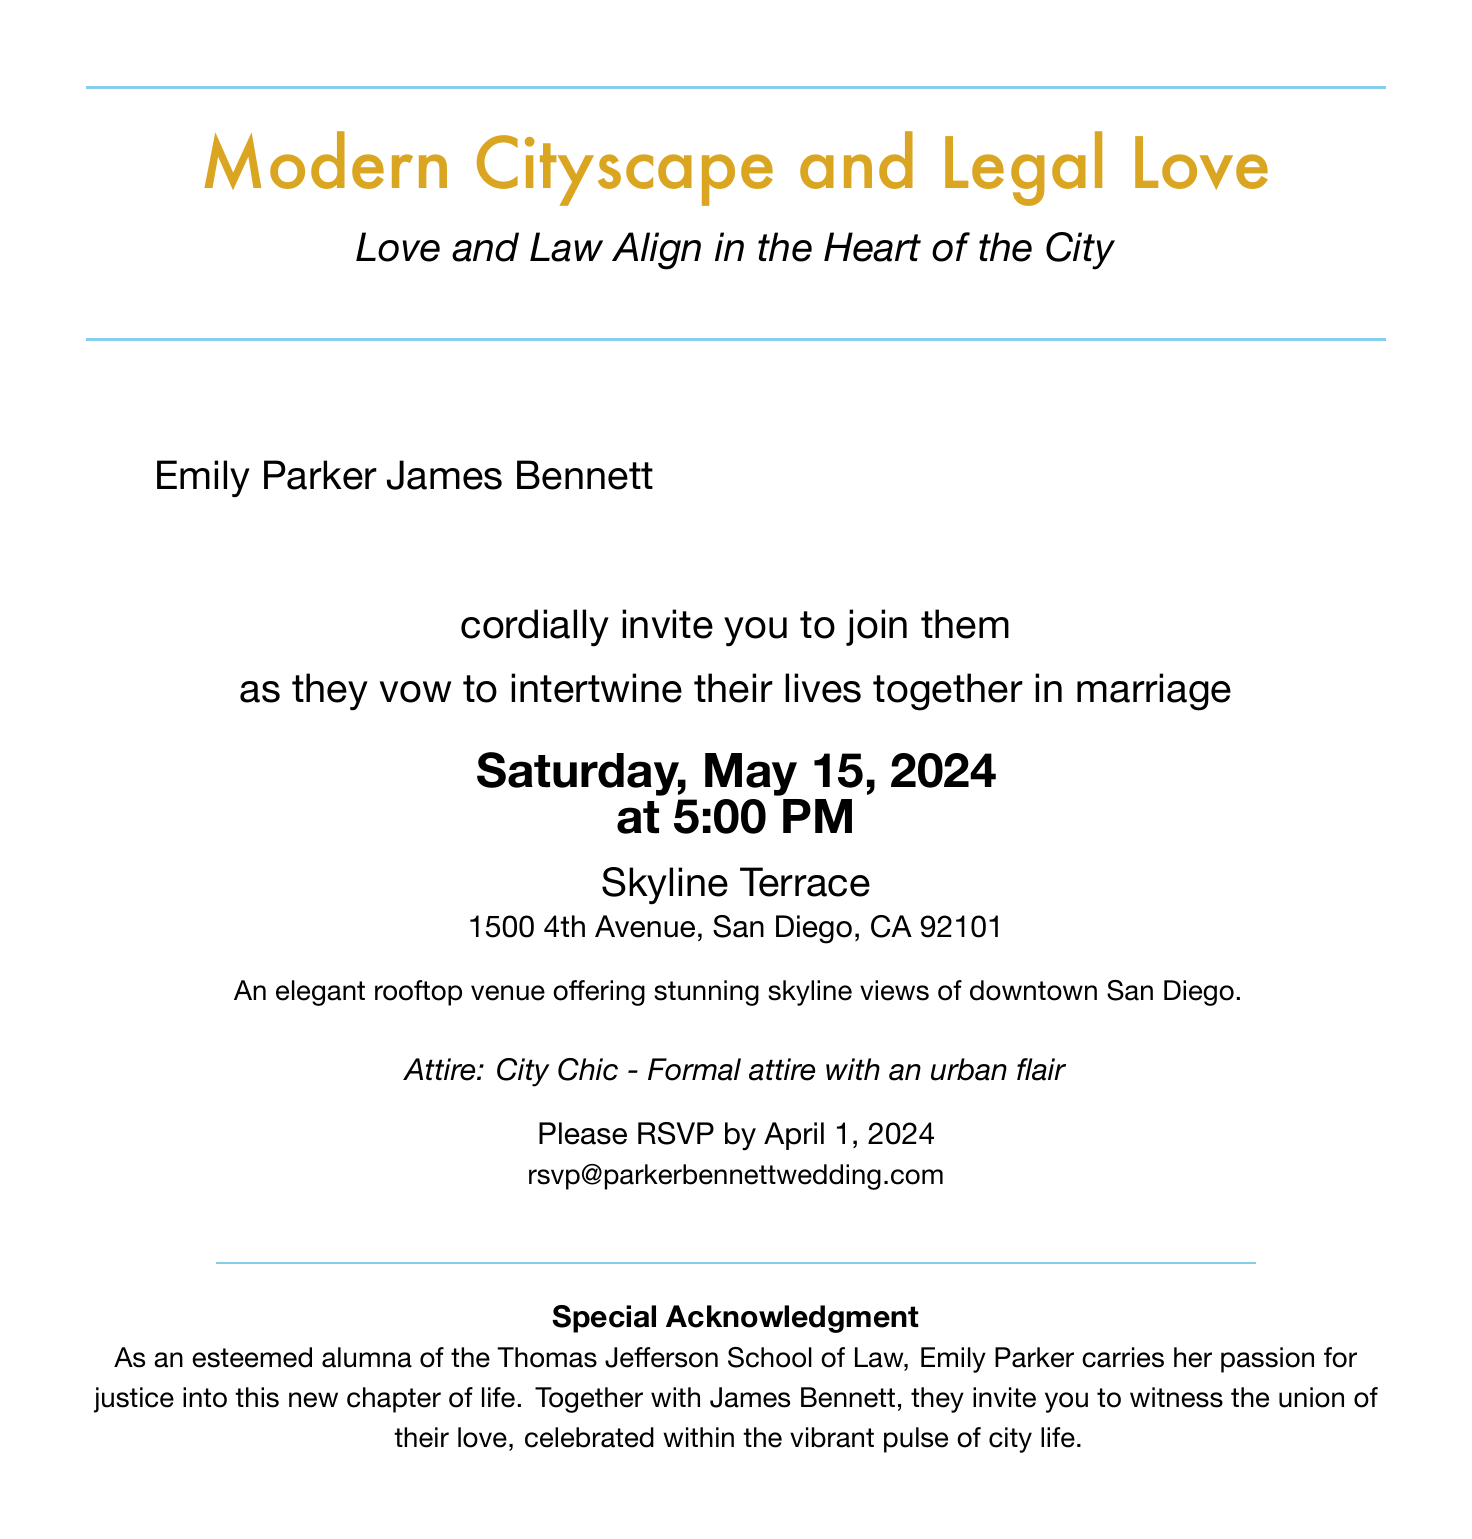What are the names of the couple? The names of the couple are mentioned in the invitation, which are Emily Parker and James Bennett.
Answer: Emily Parker and James Bennett What is the date of the wedding? The date of the wedding is clearly stated in the document, which is Saturday, May 15, 2024.
Answer: Saturday, May 15, 2024 What time does the wedding ceremony start? The start time of the wedding ceremony is detailed in the invitation, which is at 5:00 PM.
Answer: 5:00 PM What is the venue name for the ceremony? The venue where the ceremony will take place is mentioned in the invitation as Skyline Terrace.
Answer: Skyline Terrace What is the address of the venue? The address of the venue is provided in the document, which is 1500 4th Avenue, San Diego, CA 92101.
Answer: 1500 4th Avenue, San Diego, CA 92101 What type of attire is requested for the guests? The invitation specifies the type of attire requested, which is City Chic - Formal attire with an urban flair.
Answer: City Chic - Formal attire with an urban flair What is the RSVP deadline? The RSVP deadline is clearly indicated in the invitation as April 1, 2024.
Answer: April 1, 2024 What special acknowledgment is made in the invitation? A special acknowledgment is included in the document about Emily Parker's background as an alumna of Thomas Jefferson School of Law.
Answer: Alumna of the Thomas Jefferson School of Law What unique theme is reflected in the invitation design? The theme of the invitation combines elements of urban life and law, highlighting the couple's connection.
Answer: Modern Cityscape and Legal Love 